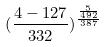Convert formula to latex. <formula><loc_0><loc_0><loc_500><loc_500>( \frac { 4 - 1 2 7 } { 3 3 2 } ) ^ { \frac { \frac { 5 } { 4 9 2 } } { 3 8 7 } }</formula> 